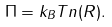<formula> <loc_0><loc_0><loc_500><loc_500>\Pi = k _ { B } T n ( R ) .</formula> 